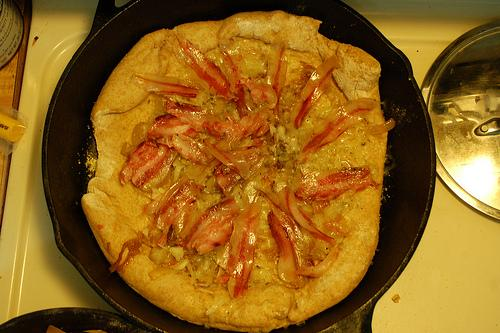What type of object appears to be present next to the other smaller skillet in the image? There is a cabbage under the onions next to the smaller skillet. Mention the color and the type of the cabinet that is located adjacent to the stove. The cabinet next to the stove is wooden and has a brown color. Express concisely the context of the image presented. The image portrays a kitchen scene with a white stove, cooking utensils, several skillets, and a pizza with various toppings. What kind of material is the handle of the large black cast iron skillet made of? The handle of the large black cast iron skillet is made of black iron. Identify what type of food is placed in the large black cast iron skillet. There is a pizza with bacon strips and caramelized onions in the large black cast iron skillet. List three different objects placed on the pizza. Bacon strips, caramelized onions, and ground sausage are placed on the pizza. What type of material is the lid of the large black cast iron skillet made of? The skillet lid is made of silver, indicating it to be a metal material. Describe how the smaller skillet in the corner appears to be different from the larger skillet on the stove. The smaller skillet is clean and not currently in use, while the large skillet has a pizza with various toppings in it on the stove. Determine if there is any visible damage or issues with the pizza in the skillet. There is burnt cabbage on the crust of the pizza in the skillet. Detect any anomalies present in the image that seems unusual for a typical kitchen setting. There is a piece of onion on the stove, a bread crumb nearby, and a plastic package next to the stove, which could be seen as unusual or messy. Is the bacon on the pizza cooked in a circular shape? The instruction is misleading because the bacon is described as strips, not circular shapes. Are there any orange carrots under the pizza? No, it's not mentioned in the image. Can you see a blue rectangular object next to the stove? The instruction is misleading because there is no mention of a blue object or any rectangular object next to the stove. Is the stove near the cabinet green in color? The instruction is misleading because the stove is described as white, not green. Is there a purple onion on top of the pizza? The instruction is misleading because the onions mentioned in the image are red, not purple. 